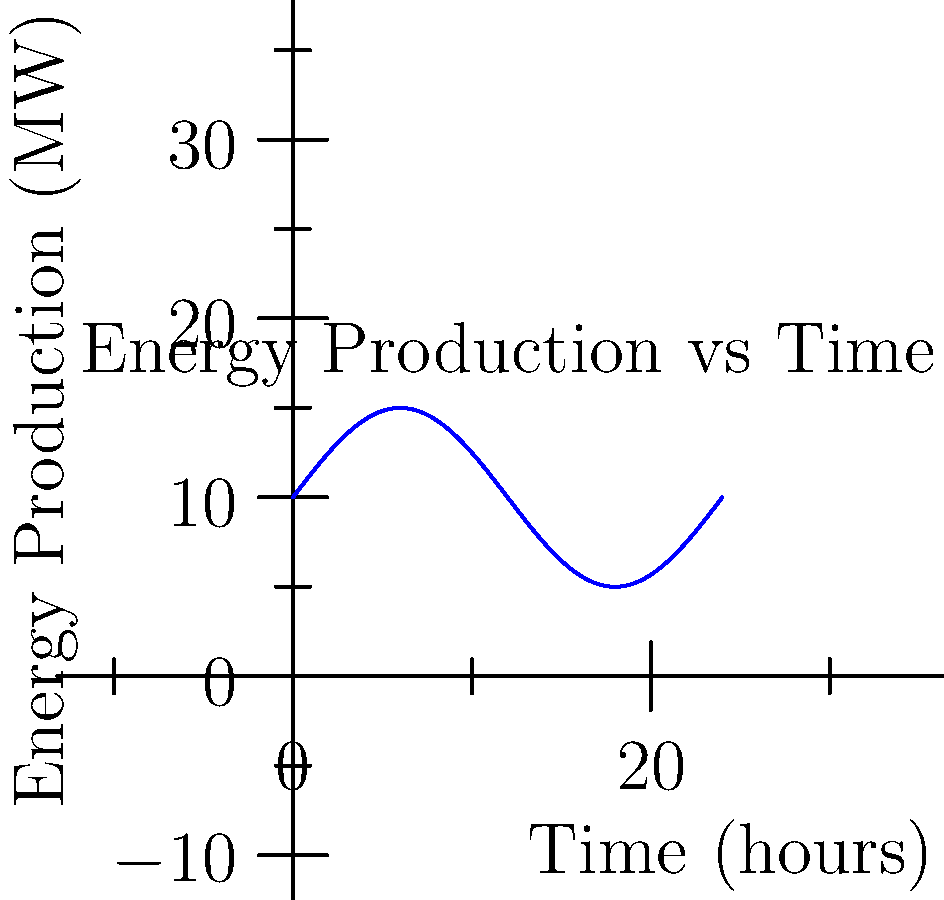As part of a local renewable energy initiative in Harrisburg, you're analyzing the daily output of a solar farm. The energy production in megawatts (MW) over a 24-hour period is modeled by the function $f(t) = 5\sin(\frac{\pi t}{12}) + 10$, where $t$ is the time in hours. Calculate the total energy produced in megawatt-hours (MWh) during this 24-hour period. To find the total energy produced, we need to calculate the area under the curve over the 24-hour period. This can be done using a definite integral.

Step 1: Set up the integral
$$\text{Total Energy} = \int_0^{24} f(t) dt = \int_0^{24} (5\sin(\frac{\pi t}{12}) + 10) dt$$

Step 2: Integrate the function
$$\int_0^{24} (5\sin(\frac{\pi t}{12}) + 10) dt = [-\frac{60}{\pi}\cos(\frac{\pi t}{12}) + 10t]_0^{24}$$

Step 3: Evaluate the integral at the limits
$$= [-\frac{60}{\pi}\cos(\frac{\pi \cdot 24}{12}) + 10 \cdot 24] - [-\frac{60}{\pi}\cos(\frac{\pi \cdot 0}{12}) + 10 \cdot 0]$$
$$= [-\frac{60}{\pi}\cos(2\pi) + 240] - [-\frac{60}{\pi} + 0]$$

Step 4: Simplify
$$= [-\frac{60}{\pi} + 240] - [-\frac{60}{\pi}]$$
$$= 240$$

Therefore, the total energy produced over the 24-hour period is 240 MWh.
Answer: 240 MWh 